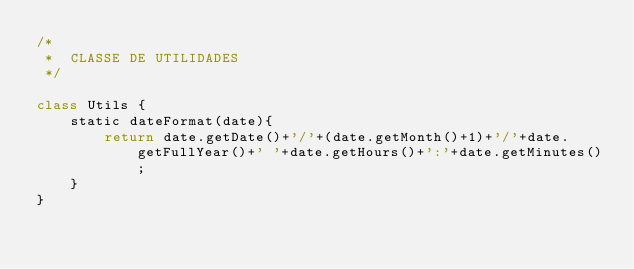<code> <loc_0><loc_0><loc_500><loc_500><_JavaScript_>/*
 *  CLASSE DE UTILIDADES 
 */

class Utils {
    static dateFormat(date){
        return date.getDate()+'/'+(date.getMonth()+1)+'/'+date.getFullYear()+' '+date.getHours()+':'+date.getMinutes();
    }
}</code> 